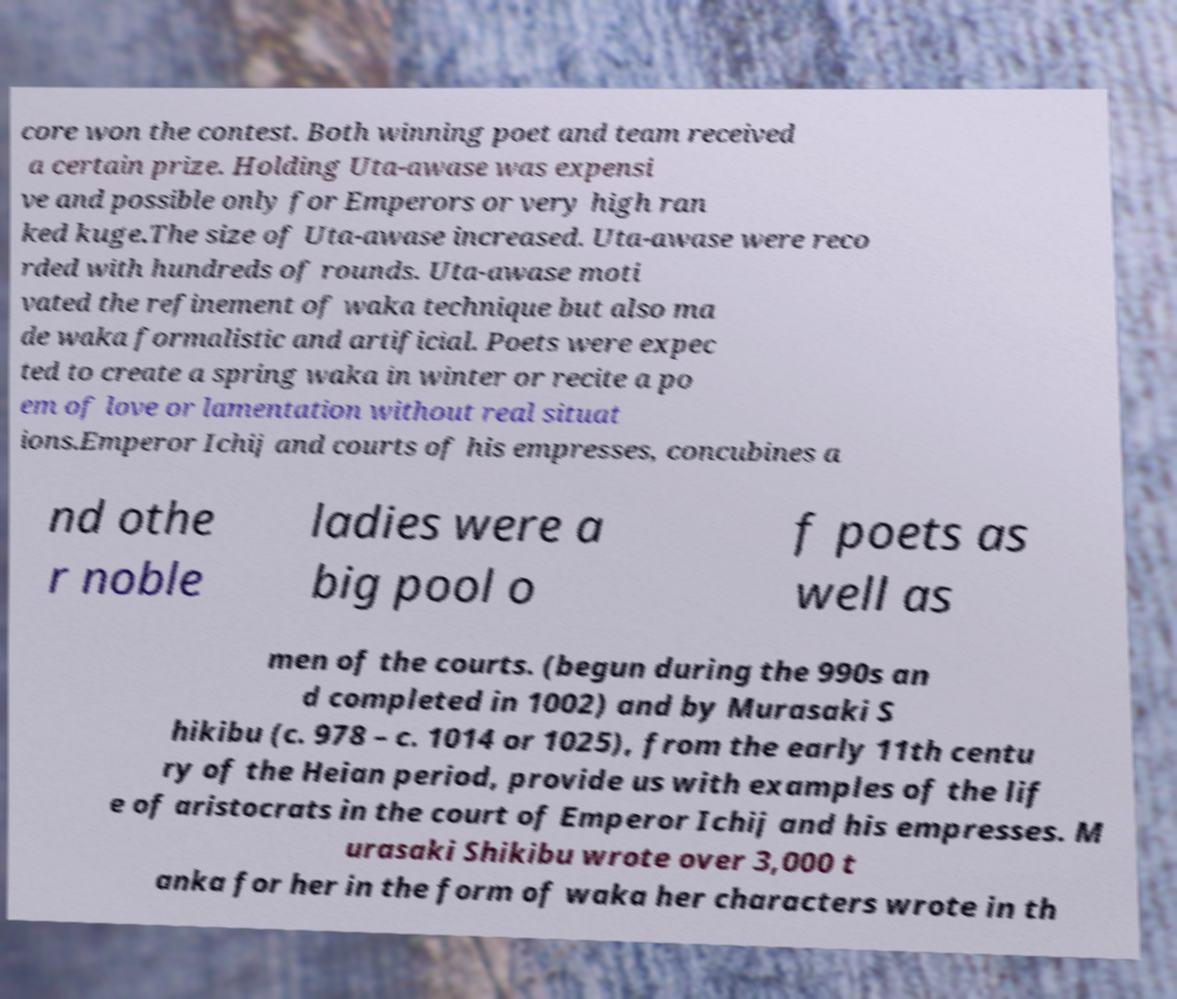What messages or text are displayed in this image? I need them in a readable, typed format. core won the contest. Both winning poet and team received a certain prize. Holding Uta-awase was expensi ve and possible only for Emperors or very high ran ked kuge.The size of Uta-awase increased. Uta-awase were reco rded with hundreds of rounds. Uta-awase moti vated the refinement of waka technique but also ma de waka formalistic and artificial. Poets were expec ted to create a spring waka in winter or recite a po em of love or lamentation without real situat ions.Emperor Ichij and courts of his empresses, concubines a nd othe r noble ladies were a big pool o f poets as well as men of the courts. (begun during the 990s an d completed in 1002) and by Murasaki S hikibu (c. 978 – c. 1014 or 1025), from the early 11th centu ry of the Heian period, provide us with examples of the lif e of aristocrats in the court of Emperor Ichij and his empresses. M urasaki Shikibu wrote over 3,000 t anka for her in the form of waka her characters wrote in th 